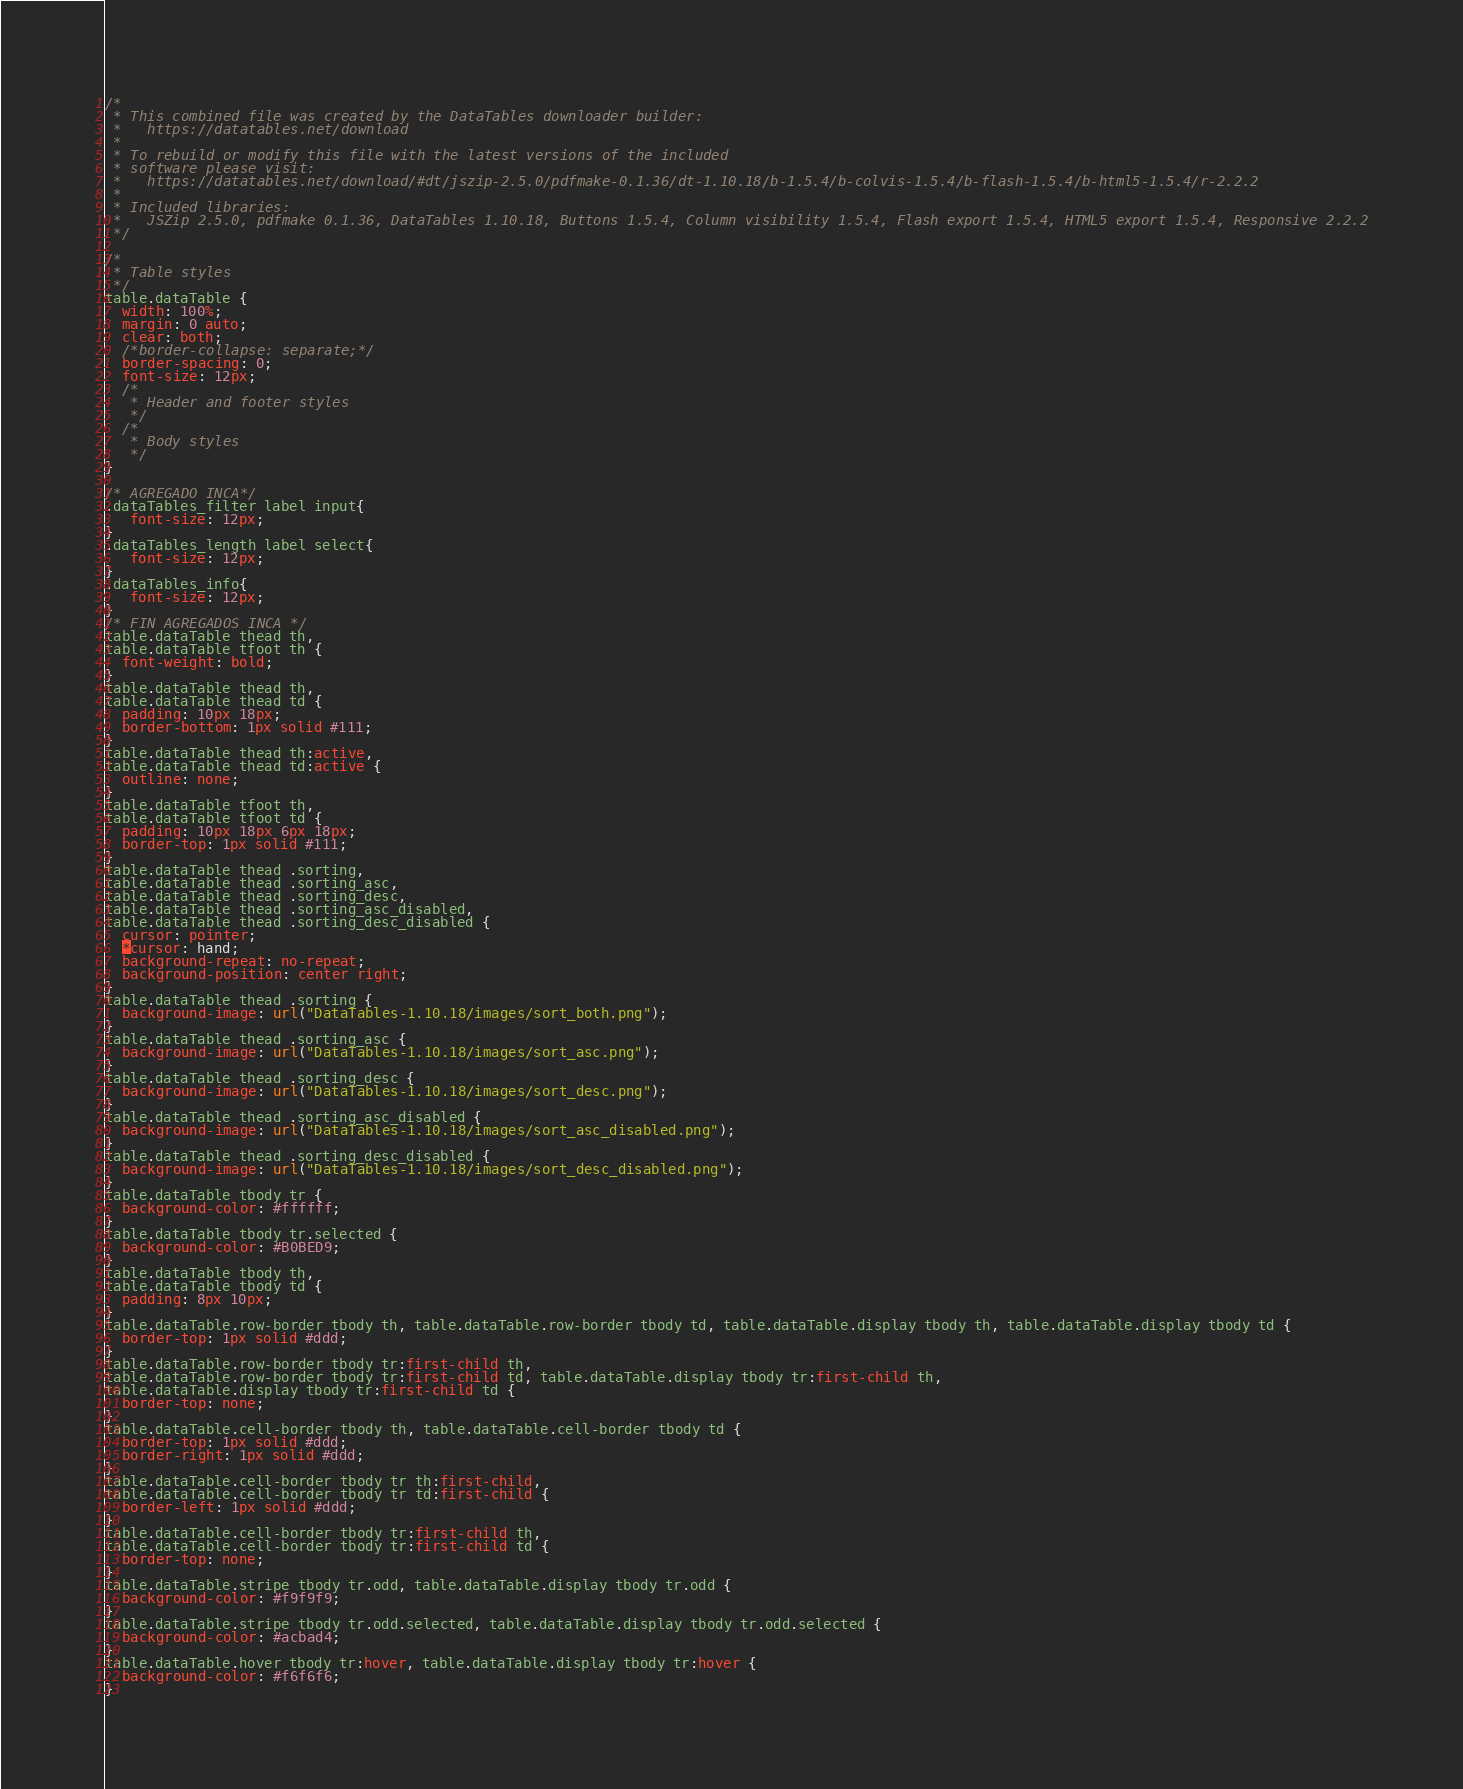<code> <loc_0><loc_0><loc_500><loc_500><_CSS_>/*
 * This combined file was created by the DataTables downloader builder:
 *   https://datatables.net/download
 *
 * To rebuild or modify this file with the latest versions of the included
 * software please visit:
 *   https://datatables.net/download/#dt/jszip-2.5.0/pdfmake-0.1.36/dt-1.10.18/b-1.5.4/b-colvis-1.5.4/b-flash-1.5.4/b-html5-1.5.4/r-2.2.2
 *
 * Included libraries:
 *   JSZip 2.5.0, pdfmake 0.1.36, DataTables 1.10.18, Buttons 1.5.4, Column visibility 1.5.4, Flash export 1.5.4, HTML5 export 1.5.4, Responsive 2.2.2
 */

/*
 * Table styles
 */
table.dataTable {
  width: 100%;
  margin: 0 auto;
  clear: both;
  /*border-collapse: separate;*/
  border-spacing: 0;
  font-size: 12px;
  /*
   * Header and footer styles
   */
  /*
   * Body styles
   */
}

/* AGREGADO INCA*/
.dataTables_filter label input{
   font-size: 12px;
}
.dataTables_length label select{
   font-size: 12px;
}
.dataTables_info{
   font-size: 12px;
}
/* FIN AGREGADOS INCA */
table.dataTable thead th,
table.dataTable tfoot th {
  font-weight: bold;
}
table.dataTable thead th,
table.dataTable thead td {
  padding: 10px 18px;
  border-bottom: 1px solid #111;
}
table.dataTable thead th:active,
table.dataTable thead td:active {
  outline: none;
}
table.dataTable tfoot th,
table.dataTable tfoot td {
  padding: 10px 18px 6px 18px;
  border-top: 1px solid #111;
}
table.dataTable thead .sorting,
table.dataTable thead .sorting_asc,
table.dataTable thead .sorting_desc,
table.dataTable thead .sorting_asc_disabled,
table.dataTable thead .sorting_desc_disabled {
  cursor: pointer;
  *cursor: hand;
  background-repeat: no-repeat;
  background-position: center right;
}
table.dataTable thead .sorting {
  background-image: url("DataTables-1.10.18/images/sort_both.png");
}
table.dataTable thead .sorting_asc {
  background-image: url("DataTables-1.10.18/images/sort_asc.png");
}
table.dataTable thead .sorting_desc {
  background-image: url("DataTables-1.10.18/images/sort_desc.png");
}
table.dataTable thead .sorting_asc_disabled {
  background-image: url("DataTables-1.10.18/images/sort_asc_disabled.png");
}
table.dataTable thead .sorting_desc_disabled {
  background-image: url("DataTables-1.10.18/images/sort_desc_disabled.png");
}
table.dataTable tbody tr {
  background-color: #ffffff;
}
table.dataTable tbody tr.selected {
  background-color: #B0BED9;
}
table.dataTable tbody th,
table.dataTable tbody td {
  padding: 8px 10px;
}
table.dataTable.row-border tbody th, table.dataTable.row-border tbody td, table.dataTable.display tbody th, table.dataTable.display tbody td {
  border-top: 1px solid #ddd;
}
table.dataTable.row-border tbody tr:first-child th,
table.dataTable.row-border tbody tr:first-child td, table.dataTable.display tbody tr:first-child th,
table.dataTable.display tbody tr:first-child td {
  border-top: none;
}
table.dataTable.cell-border tbody th, table.dataTable.cell-border tbody td {
  border-top: 1px solid #ddd;
  border-right: 1px solid #ddd;
}
table.dataTable.cell-border tbody tr th:first-child,
table.dataTable.cell-border tbody tr td:first-child {
  border-left: 1px solid #ddd;
}
table.dataTable.cell-border tbody tr:first-child th,
table.dataTable.cell-border tbody tr:first-child td {
  border-top: none;
}
table.dataTable.stripe tbody tr.odd, table.dataTable.display tbody tr.odd {
  background-color: #f9f9f9;
}
table.dataTable.stripe tbody tr.odd.selected, table.dataTable.display tbody tr.odd.selected {
  background-color: #acbad4;
}
table.dataTable.hover tbody tr:hover, table.dataTable.display tbody tr:hover {
  background-color: #f6f6f6;
}</code> 